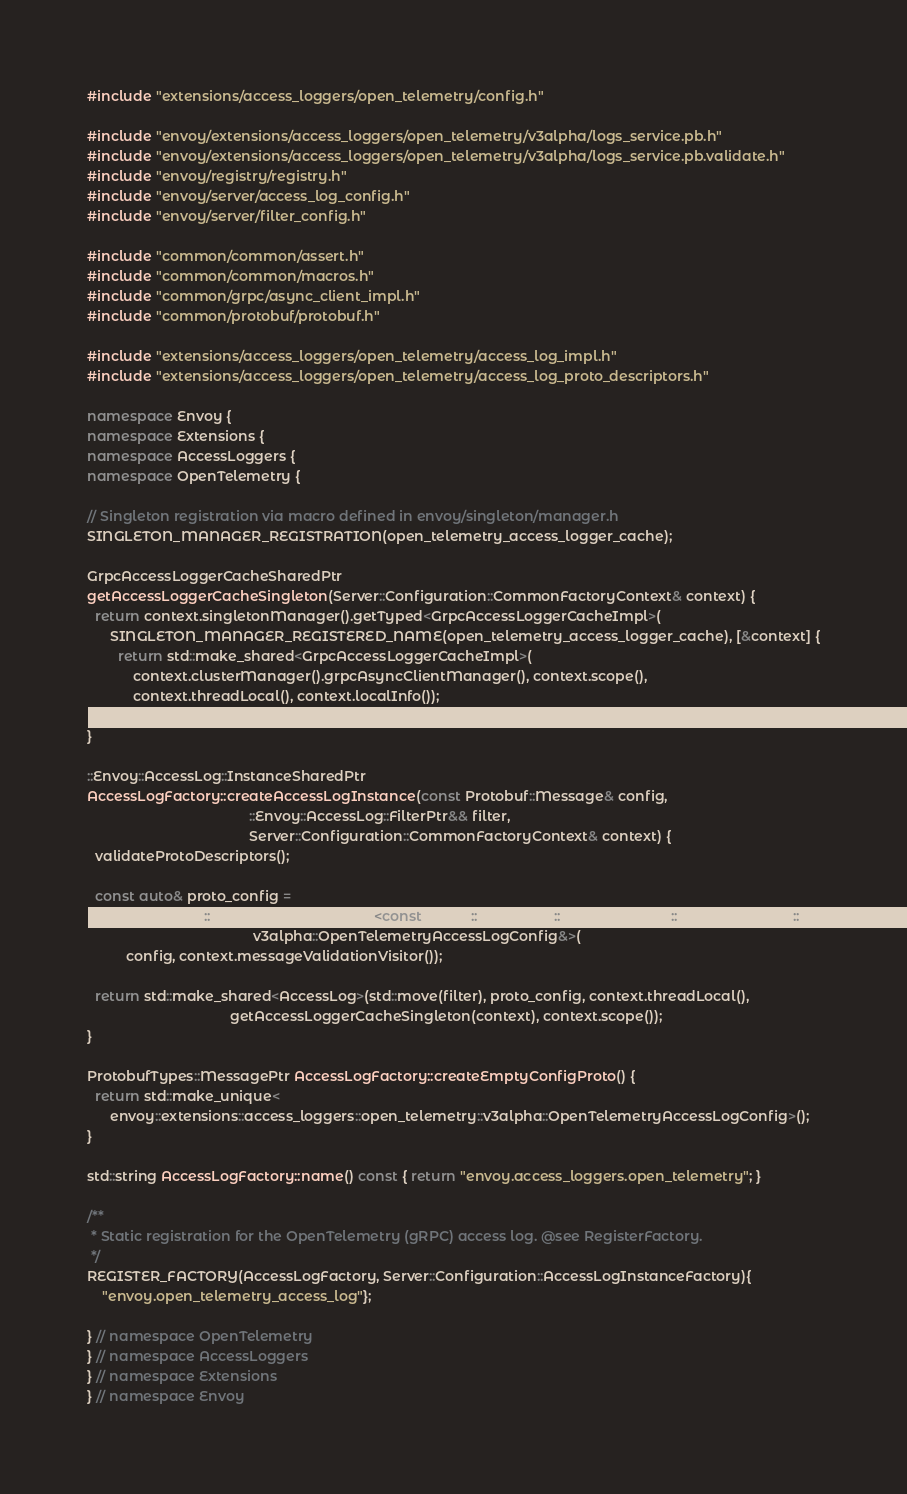<code> <loc_0><loc_0><loc_500><loc_500><_C++_>#include "extensions/access_loggers/open_telemetry/config.h"

#include "envoy/extensions/access_loggers/open_telemetry/v3alpha/logs_service.pb.h"
#include "envoy/extensions/access_loggers/open_telemetry/v3alpha/logs_service.pb.validate.h"
#include "envoy/registry/registry.h"
#include "envoy/server/access_log_config.h"
#include "envoy/server/filter_config.h"

#include "common/common/assert.h"
#include "common/common/macros.h"
#include "common/grpc/async_client_impl.h"
#include "common/protobuf/protobuf.h"

#include "extensions/access_loggers/open_telemetry/access_log_impl.h"
#include "extensions/access_loggers/open_telemetry/access_log_proto_descriptors.h"

namespace Envoy {
namespace Extensions {
namespace AccessLoggers {
namespace OpenTelemetry {

// Singleton registration via macro defined in envoy/singleton/manager.h
SINGLETON_MANAGER_REGISTRATION(open_telemetry_access_logger_cache);

GrpcAccessLoggerCacheSharedPtr
getAccessLoggerCacheSingleton(Server::Configuration::CommonFactoryContext& context) {
  return context.singletonManager().getTyped<GrpcAccessLoggerCacheImpl>(
      SINGLETON_MANAGER_REGISTERED_NAME(open_telemetry_access_logger_cache), [&context] {
        return std::make_shared<GrpcAccessLoggerCacheImpl>(
            context.clusterManager().grpcAsyncClientManager(), context.scope(),
            context.threadLocal(), context.localInfo());
      });
}

::Envoy::AccessLog::InstanceSharedPtr
AccessLogFactory::createAccessLogInstance(const Protobuf::Message& config,
                                          ::Envoy::AccessLog::FilterPtr&& filter,
                                          Server::Configuration::CommonFactoryContext& context) {
  validateProtoDescriptors();

  const auto& proto_config =
      MessageUtil::downcastAndValidate<const envoy::extensions::access_loggers::open_telemetry::
                                           v3alpha::OpenTelemetryAccessLogConfig&>(
          config, context.messageValidationVisitor());

  return std::make_shared<AccessLog>(std::move(filter), proto_config, context.threadLocal(),
                                     getAccessLoggerCacheSingleton(context), context.scope());
}

ProtobufTypes::MessagePtr AccessLogFactory::createEmptyConfigProto() {
  return std::make_unique<
      envoy::extensions::access_loggers::open_telemetry::v3alpha::OpenTelemetryAccessLogConfig>();
}

std::string AccessLogFactory::name() const { return "envoy.access_loggers.open_telemetry"; }

/**
 * Static registration for the OpenTelemetry (gRPC) access log. @see RegisterFactory.
 */
REGISTER_FACTORY(AccessLogFactory, Server::Configuration::AccessLogInstanceFactory){
    "envoy.open_telemetry_access_log"};

} // namespace OpenTelemetry
} // namespace AccessLoggers
} // namespace Extensions
} // namespace Envoy
</code> 